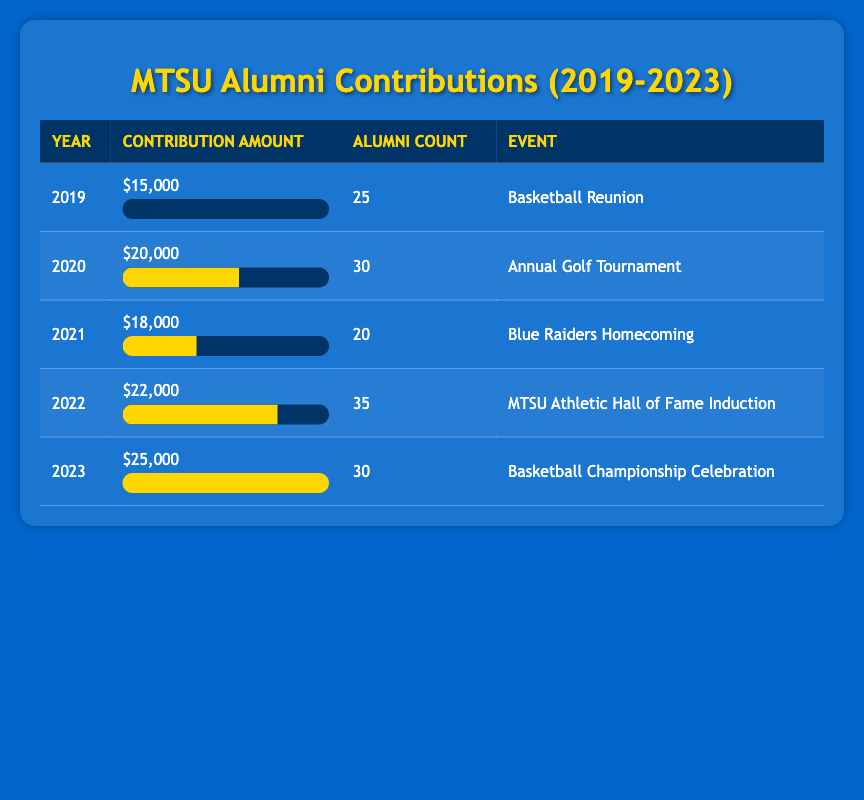What was the total contribution amount in 2021? From the table, the contribution amount for 2021 is listed as $18,000. Therefore, the total contribution amount for that year is simply what is stated in the table.
Answer: $18,000 Which year had the highest alumni count? Looking through the table, the year with the highest alumni count is 2022, with 35 alumni participating in the event. This can be verified by comparing the figures listed for each year.
Answer: 2022 What was the average contribution amount over the five years? To find the average contribution amount, we need to add the contributions from all five years: $15,000 + $20,000 + $18,000 + $22,000 + $25,000 = $100,000. There are 5 years, so we divide $100,000 by 5, which gives an average of $20,000.
Answer: $20,000 Did alumni contributions increase every year? By examining the contribution amounts from each year: 2019 ($15,000), 2020 ($20,000), 2021 ($18,000), 2022 ($22,000), and 2023 ($25,000), it can be observed that 2021 shows a decrease compared to 2020. Thus, contributions did not increase every year.
Answer: No What was the difference in contribution amount between 2019 and 2023? The contribution amount for 2019 is $15,000, and for 2023 it is $25,000. The difference is calculated by subtracting the earlier year from the later year: $25,000 - $15,000 = $10,000.
Answer: $10,000 